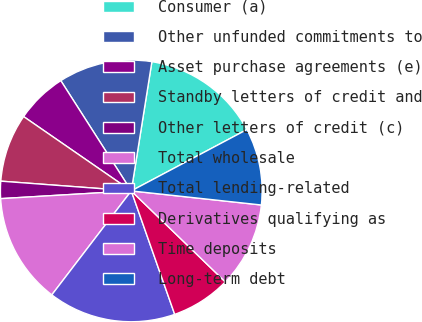Convert chart to OTSL. <chart><loc_0><loc_0><loc_500><loc_500><pie_chart><fcel>Consumer (a)<fcel>Other unfunded commitments to<fcel>Asset purchase agreements (e)<fcel>Standby letters of credit and<fcel>Other letters of credit (c)<fcel>Total wholesale<fcel>Total lending-related<fcel>Derivatives qualifying as<fcel>Time deposits<fcel>Long-term debt<nl><fcel>14.72%<fcel>11.57%<fcel>6.33%<fcel>8.43%<fcel>2.13%<fcel>13.67%<fcel>15.77%<fcel>7.38%<fcel>10.52%<fcel>9.48%<nl></chart> 